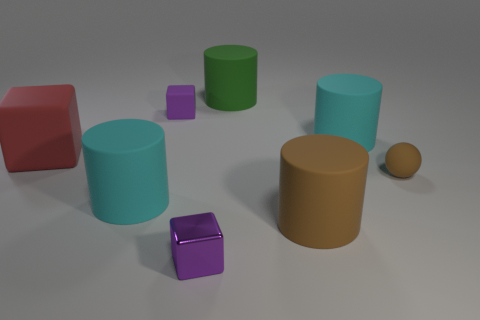What number of other things are the same material as the big red block?
Your answer should be compact. 6. Does the big thing to the right of the big brown matte thing have the same material as the red object?
Offer a very short reply. Yes. What is the size of the matte thing to the left of the cyan matte cylinder that is to the left of the purple block in front of the small brown matte thing?
Offer a terse response. Large. What number of other objects are there of the same color as the metallic cube?
Ensure brevity in your answer.  1. There is a brown thing that is the same size as the green cylinder; what is its shape?
Give a very brief answer. Cylinder. There is a cyan rubber cylinder left of the green object; how big is it?
Ensure brevity in your answer.  Large. Do the rubber cylinder that is right of the big brown cylinder and the tiny object to the right of the green cylinder have the same color?
Give a very brief answer. No. What is the purple block that is behind the big matte cube that is to the left of the big cyan object left of the small purple rubber thing made of?
Offer a very short reply. Rubber. Is there a brown cylinder that has the same size as the red cube?
Your answer should be very brief. Yes. There is a brown cylinder that is the same size as the green matte thing; what material is it?
Give a very brief answer. Rubber. 